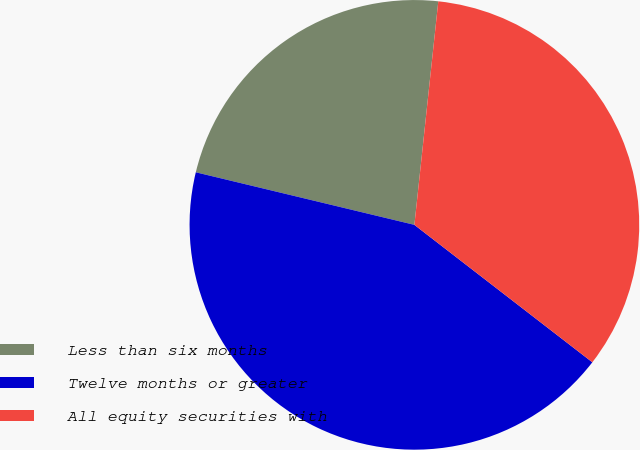Convert chart. <chart><loc_0><loc_0><loc_500><loc_500><pie_chart><fcel>Less than six months<fcel>Twelve months or greater<fcel>All equity securities with<nl><fcel>22.94%<fcel>43.29%<fcel>33.77%<nl></chart> 